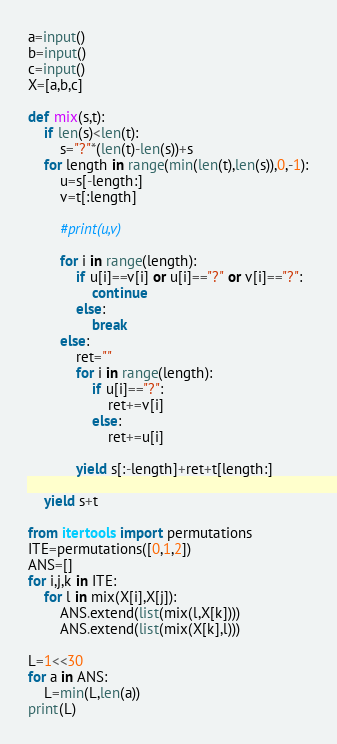<code> <loc_0><loc_0><loc_500><loc_500><_Python_>a=input()
b=input()
c=input()
X=[a,b,c]

def mix(s,t):
    if len(s)<len(t):
        s="?"*(len(t)-len(s))+s
    for length in range(min(len(t),len(s)),0,-1):
        u=s[-length:]
        v=t[:length]

        #print(u,v)

        for i in range(length):
            if u[i]==v[i] or u[i]=="?" or v[i]=="?":
                continue
            else:
                break
        else:
            ret=""
            for i in range(length):
                if u[i]=="?":
                    ret+=v[i]
                else:
                    ret+=u[i]
                
            yield s[:-length]+ret+t[length:]

    yield s+t

from itertools import permutations
ITE=permutations([0,1,2])
ANS=[]
for i,j,k in ITE:
    for l in mix(X[i],X[j]):
        ANS.extend(list(mix(l,X[k])))
        ANS.extend(list(mix(X[k],l)))

L=1<<30
for a in ANS:
    L=min(L,len(a))
print(L)
</code> 